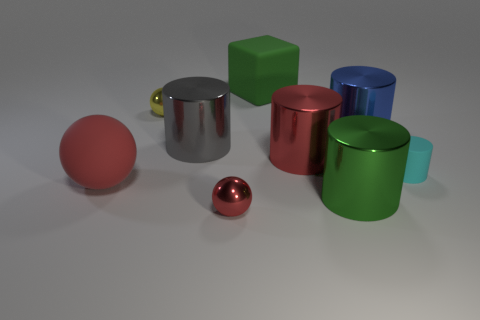Is the size of the cylinder that is in front of the cyan cylinder the same as the metal object that is to the right of the green cylinder?
Ensure brevity in your answer.  Yes. What material is the cylinder that is both right of the green shiny cylinder and behind the cyan matte object?
Your answer should be very brief. Metal. Are there fewer yellow metal things than large yellow things?
Provide a succinct answer. No. There is a red metal object that is behind the big cylinder in front of the rubber ball; how big is it?
Offer a very short reply. Large. There is a green object in front of the large shiny cylinder on the right side of the green thing in front of the small rubber thing; what is its shape?
Offer a terse response. Cylinder. The large block that is the same material as the small cyan cylinder is what color?
Offer a terse response. Green. There is a small thing behind the rubber cylinder right of the large matte object behind the large red matte sphere; what color is it?
Your answer should be very brief. Yellow. How many cubes are small blue metal things or big red metal things?
Make the answer very short. 0. Does the big ball have the same color as the tiny metallic object that is in front of the blue metal cylinder?
Give a very brief answer. Yes. The rubber sphere is what color?
Offer a terse response. Red. 